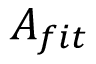Convert formula to latex. <formula><loc_0><loc_0><loc_500><loc_500>A _ { f i t }</formula> 